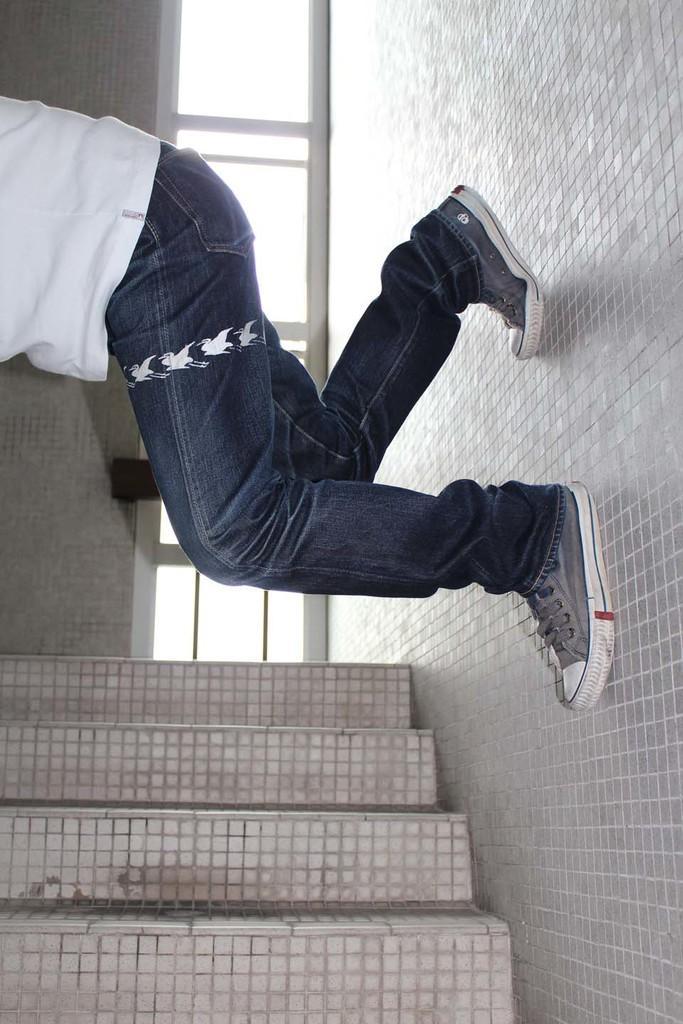Please provide a concise description of this image. In this picture we can see a person standing here, the person wore a t-shirt, jeans and shoes, we can see a wall here, there are some tiles here. 